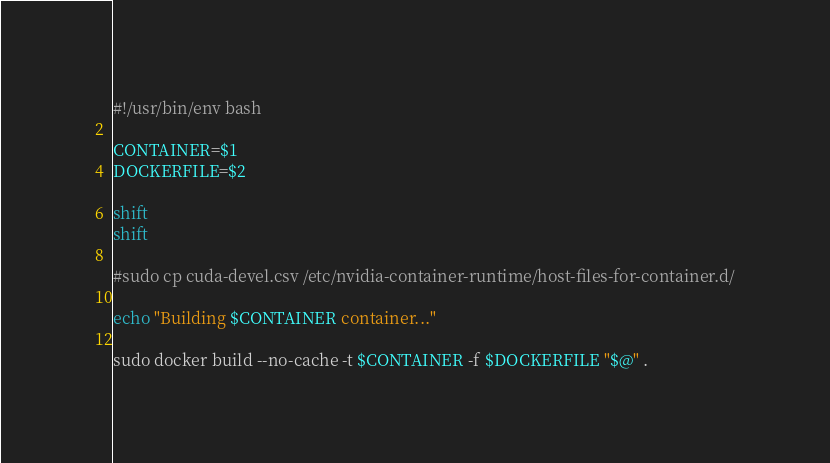<code> <loc_0><loc_0><loc_500><loc_500><_Bash_>#!/usr/bin/env bash

CONTAINER=$1
DOCKERFILE=$2

shift
shift

#sudo cp cuda-devel.csv /etc/nvidia-container-runtime/host-files-for-container.d/

echo "Building $CONTAINER container..."

sudo docker build --no-cache -t $CONTAINER -f $DOCKERFILE "$@" .
</code> 